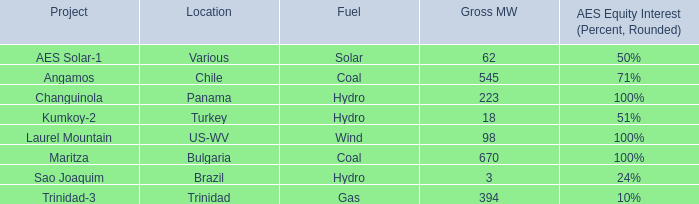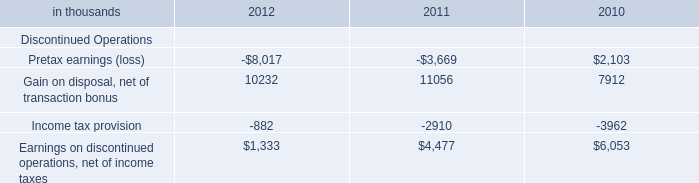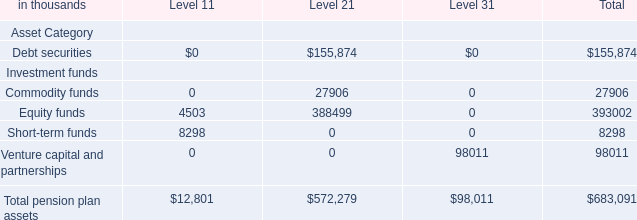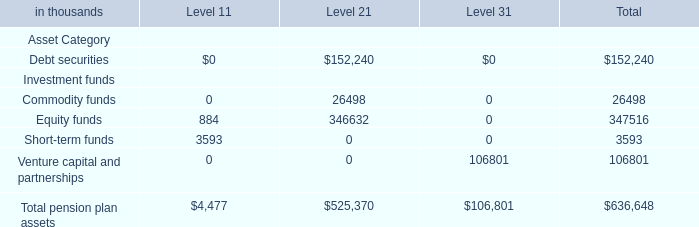In which Level is the value of Debt securities the most? 
Answer: 2. 